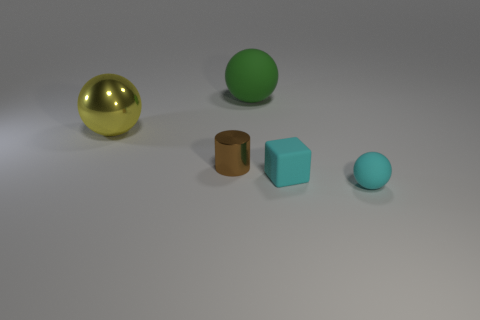Subtract all cyan matte balls. How many balls are left? 2 Add 5 green matte balls. How many objects exist? 10 Subtract all cyan balls. How many balls are left? 2 Subtract 0 purple blocks. How many objects are left? 5 Subtract all blocks. How many objects are left? 4 Subtract all yellow cubes. Subtract all purple balls. How many cubes are left? 1 Subtract all metallic cylinders. Subtract all yellow things. How many objects are left? 3 Add 5 brown objects. How many brown objects are left? 6 Add 5 small cyan cylinders. How many small cyan cylinders exist? 5 